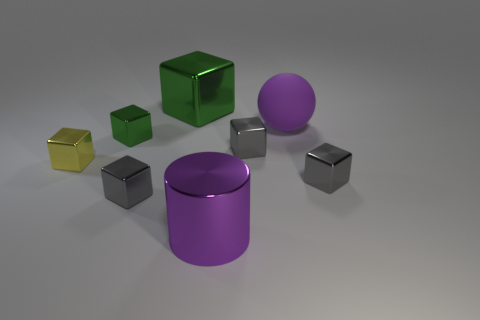How many gray cubes must be subtracted to get 1 gray cubes? 2 Subtract all red balls. How many gray blocks are left? 3 Subtract 2 cubes. How many cubes are left? 4 Subtract all yellow blocks. How many blocks are left? 5 Subtract all big blocks. How many blocks are left? 5 Subtract all brown cubes. Subtract all yellow cylinders. How many cubes are left? 6 Add 2 large metal cubes. How many objects exist? 10 Subtract all spheres. How many objects are left? 7 Subtract all purple matte things. Subtract all yellow metallic blocks. How many objects are left? 6 Add 7 big green metal objects. How many big green metal objects are left? 8 